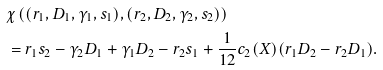Convert formula to latex. <formula><loc_0><loc_0><loc_500><loc_500>& \chi \left ( ( r _ { 1 } , D _ { 1 } , \gamma _ { 1 } , s _ { 1 } ) , ( r _ { 2 } , D _ { 2 } , \gamma _ { 2 } , s _ { 2 } ) \right ) \\ & = r _ { 1 } s _ { 2 } - \gamma _ { 2 } D _ { 1 } + \gamma _ { 1 } D _ { 2 } - r _ { 2 } s _ { 1 } + \frac { 1 } { 1 2 } c _ { 2 } ( X ) ( r _ { 1 } D _ { 2 } - r _ { 2 } D _ { 1 } ) .</formula> 